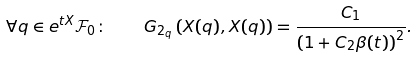Convert formula to latex. <formula><loc_0><loc_0><loc_500><loc_500>\forall q \in e ^ { t X } { \mathcal { F } } _ { 0 } \colon \quad G _ { 2 _ { q } } \left ( X ( q ) , X ( q ) \right ) = \frac { C _ { 1 } } { \left ( 1 + C _ { 2 } \beta ( t ) \right ) ^ { 2 } } .</formula> 